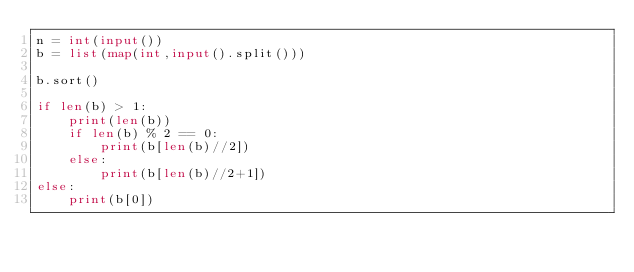Convert code to text. <code><loc_0><loc_0><loc_500><loc_500><_Python_>n = int(input())
b = list(map(int,input().split()))

b.sort()

if len(b) > 1:
    print(len(b))
    if len(b) % 2 == 0:
        print(b[len(b)//2])
    else:
        print(b[len(b)//2+1])
else:
    print(b[0])</code> 